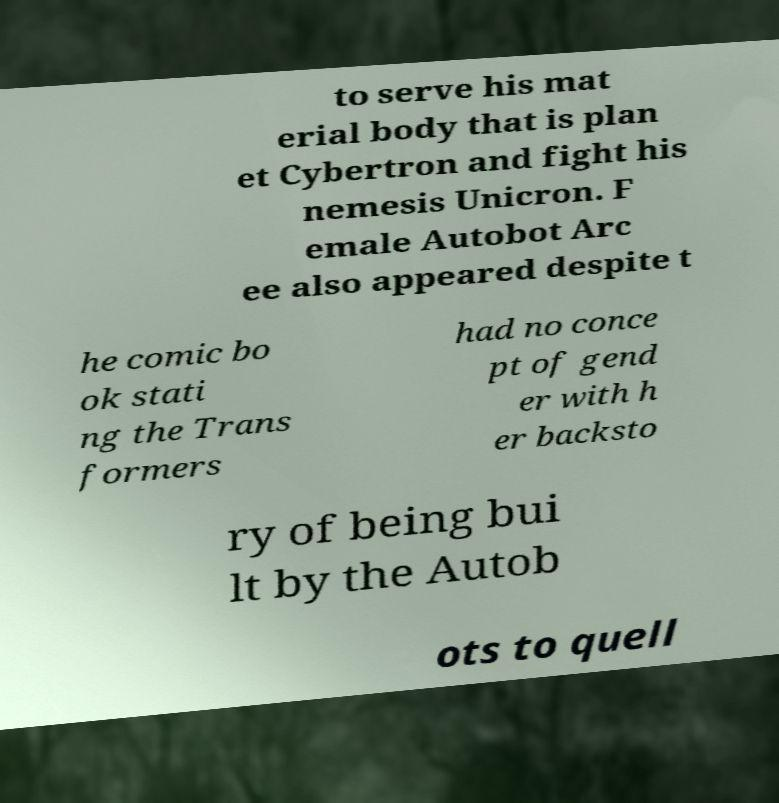For documentation purposes, I need the text within this image transcribed. Could you provide that? to serve his mat erial body that is plan et Cybertron and fight his nemesis Unicron. F emale Autobot Arc ee also appeared despite t he comic bo ok stati ng the Trans formers had no conce pt of gend er with h er backsto ry of being bui lt by the Autob ots to quell 